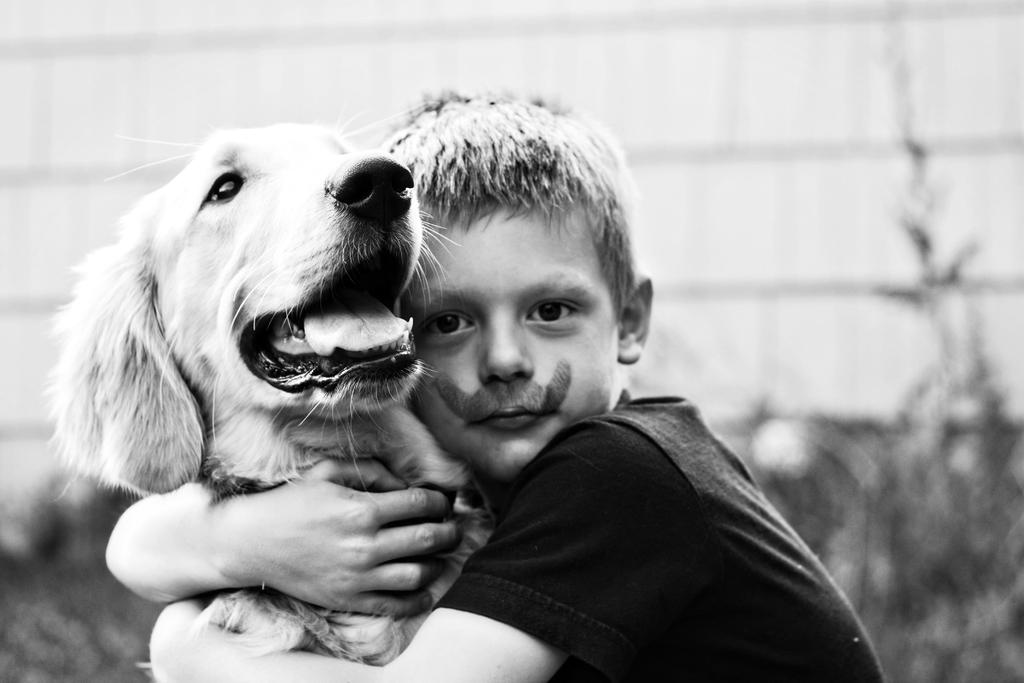What is the color scheme of the image? The image is a black and white image. Who is present in the image? There is a boy in the image. What is the boy doing in the image? The boy is hugging a dog. Can you describe the background of the image? The background of the image is blurry. What type of bat can be seen flying in the image? There is no bat present in the image; it is a black and white image of a boy hugging a dog. What flavor of soda is the boy holding in the image? There is no soda present in the image; the boy is hugging a dog. 